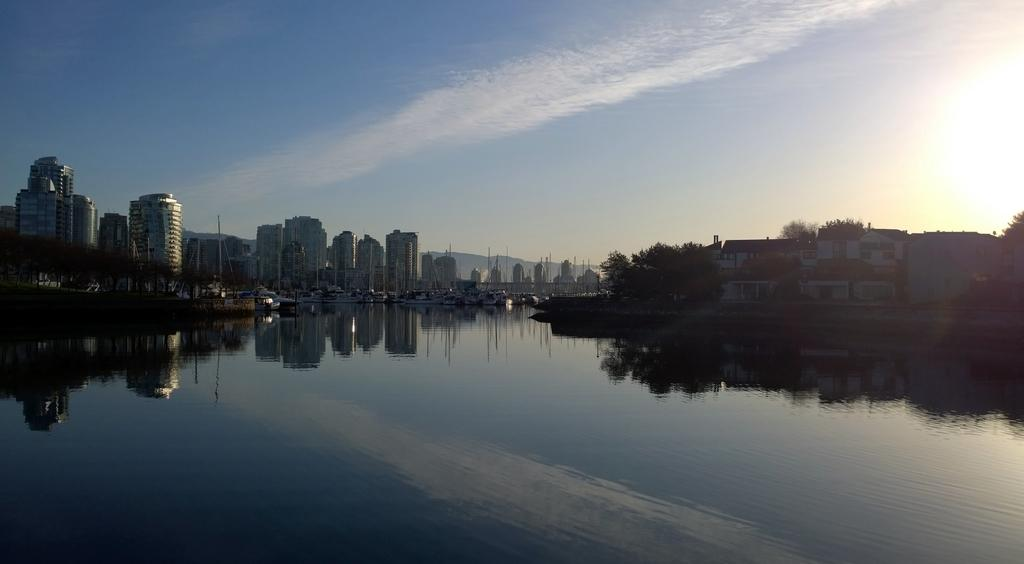What can be seen in the sky in the image? The sky is visible in the image, and clouds are present. What type of structures are in the image? There are buildings in the image. What type of vegetation is present in the image? Trees are present in the image. What natural element is visible in the image? There is water visible in the image. What can be observed on the water's surface? There are reflections of objects on the water. Where is the rake being used in the image? There is no rake present in the image. What type of paste is being applied to the trees in the image? There is no paste being applied to the trees in the image. 